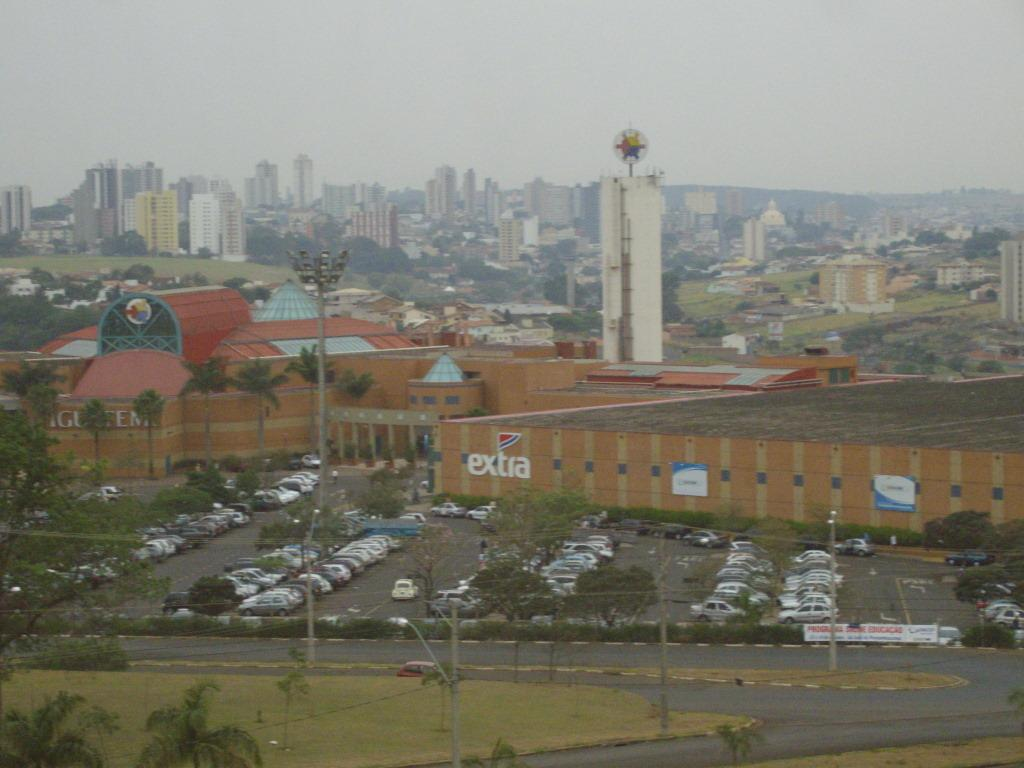What type of view is shown in the image? The image is an aerial view. What can be seen on the ground in the image? There are roads, cars, trees, and buildings visible in the image. What is visible in the sky in the image? The sky is visible in the image. How long does it take for the trees to sleep in the image? Trees do not sleep, and there is no indication of time in the image. 